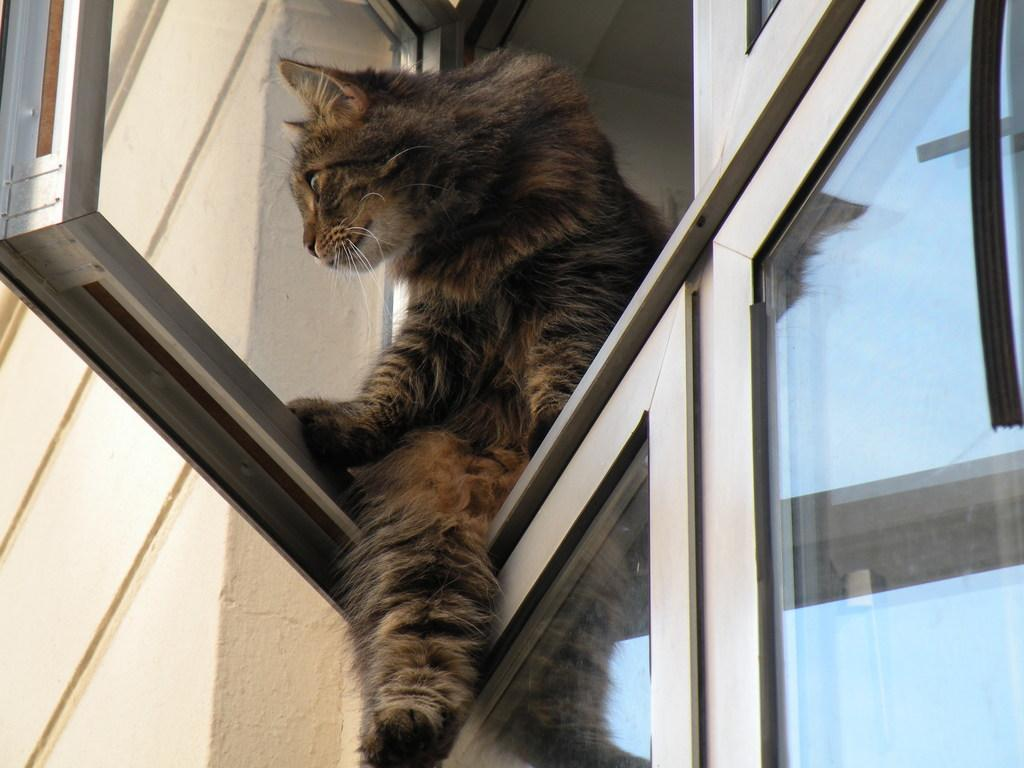What animal can be seen in the image? There is a cat in the image. Where is the cat located? The cat is sitting on a window. What is visible on the left side of the image? There is a wall on the left side of the image. What type of wood can be seen in the image? There is no wood present in the image; it features a cat sitting on a window and a wall on the left side. What does the cat's skin feel like in the image? We cannot determine the texture of the cat's skin from the image alone. 